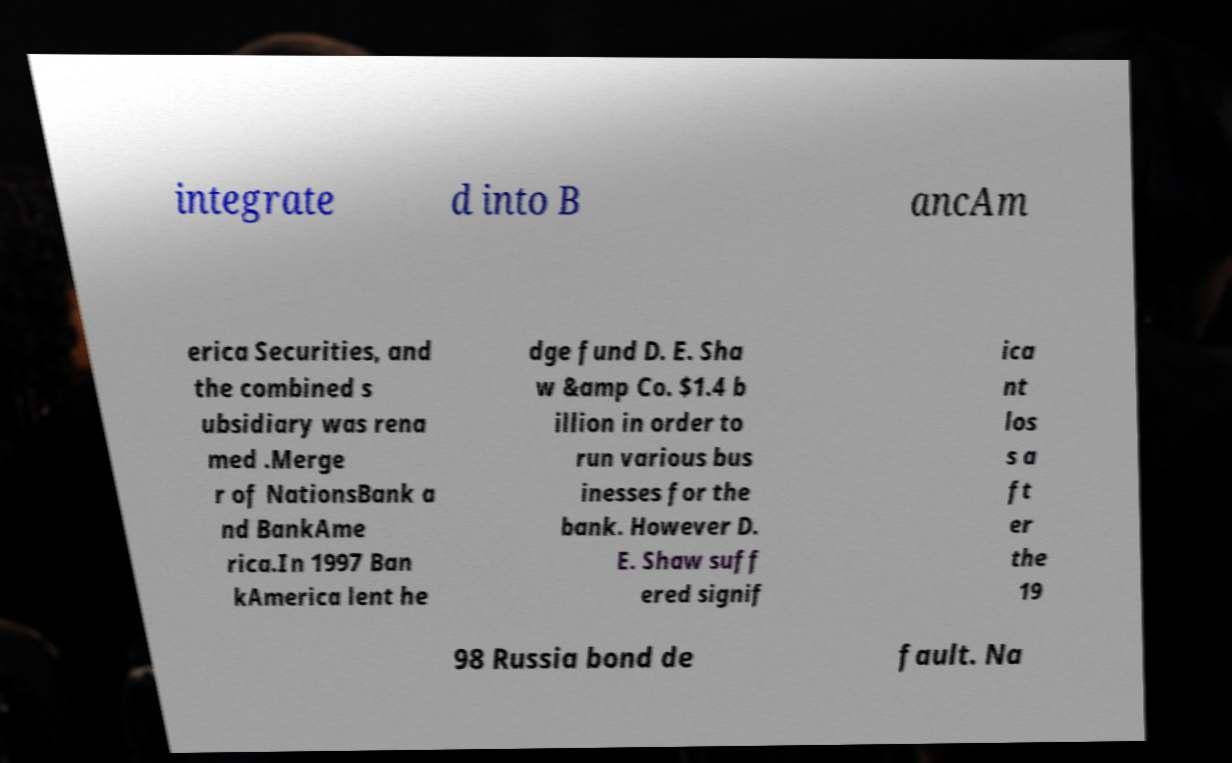Please identify and transcribe the text found in this image. integrate d into B ancAm erica Securities, and the combined s ubsidiary was rena med .Merge r of NationsBank a nd BankAme rica.In 1997 Ban kAmerica lent he dge fund D. E. Sha w &amp Co. $1.4 b illion in order to run various bus inesses for the bank. However D. E. Shaw suff ered signif ica nt los s a ft er the 19 98 Russia bond de fault. Na 